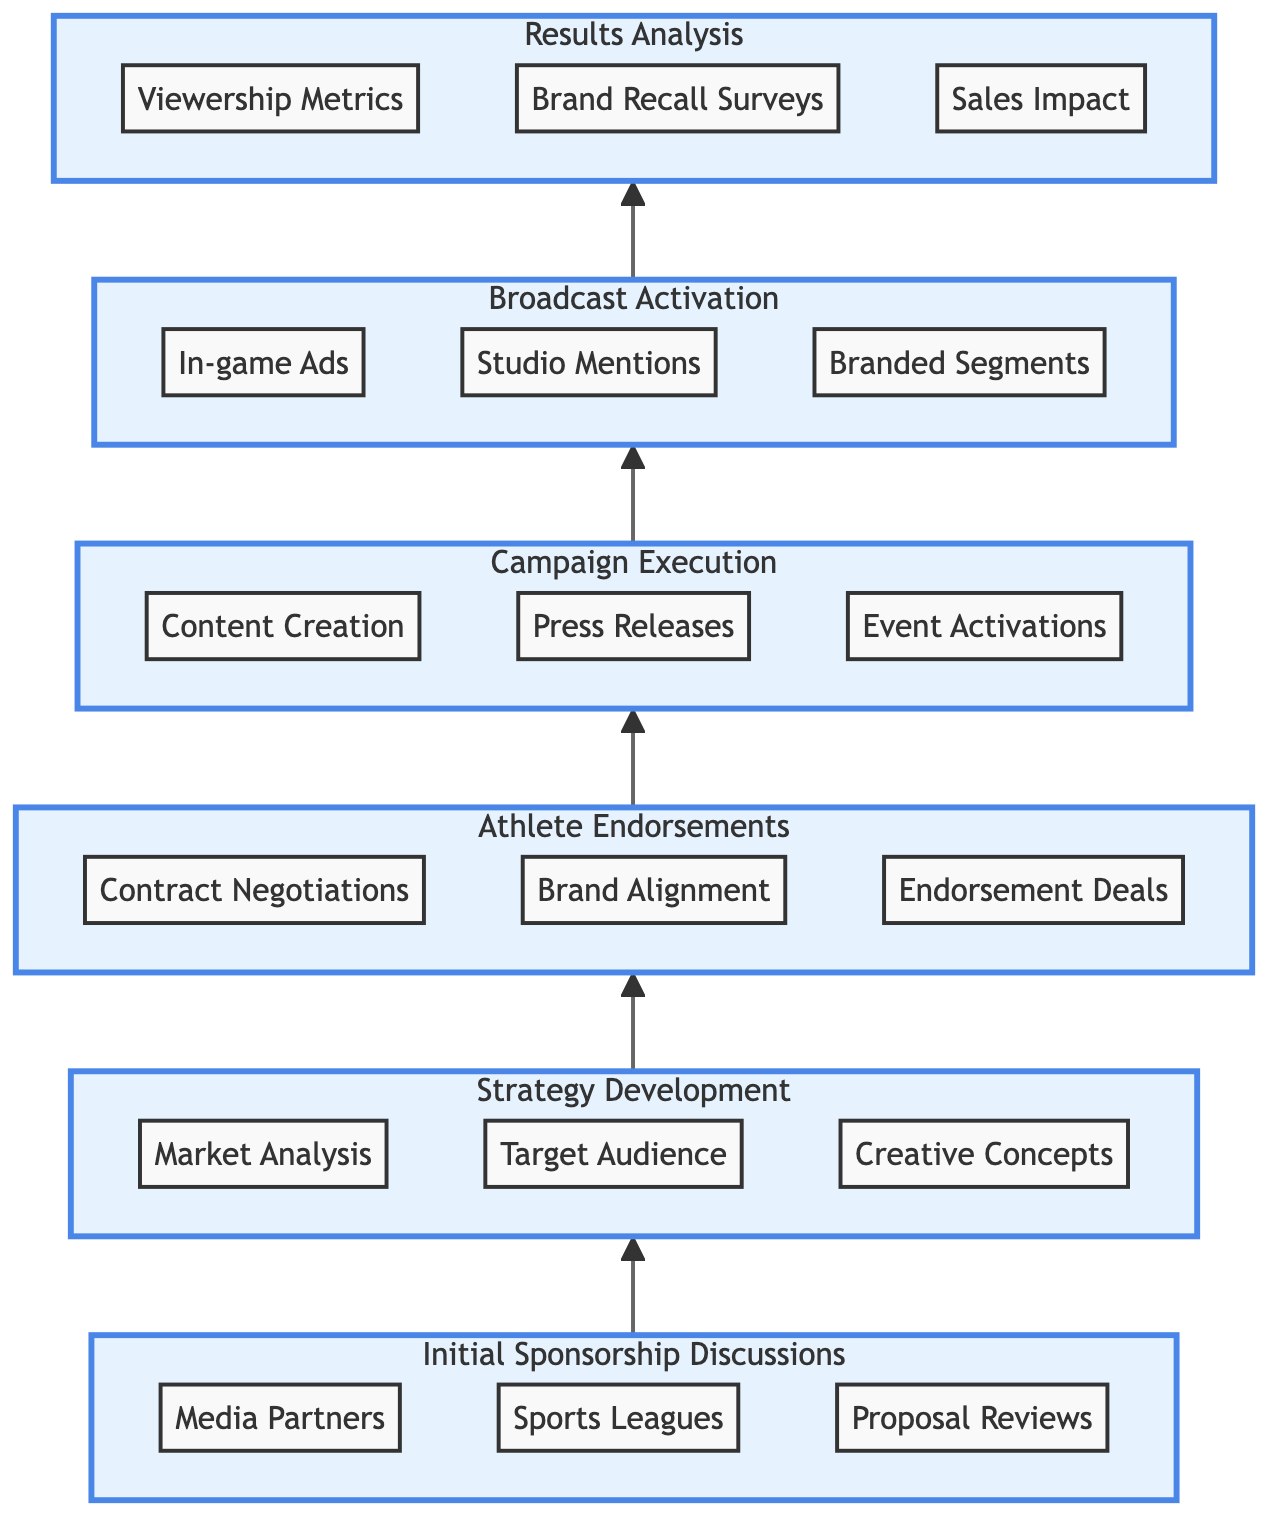What is the first step in the process? The diagram indicates that the first step is "Initial Sponsorship Discussions," which is positioned at the bottom as the starting point of the flow.
Answer: Initial Sponsorship Discussions How many main steps are outlined in the process? By counting the nodes in the diagram, there are five main steps listed: Initial Sponsorship Discussions, Strategy Development, Athlete Endorsements, Campaign Execution, and Results Analysis.
Answer: Five What is the last step of the process? The last step in the process, which is at the top of the diagram, is "Results Analysis."
Answer: Results Analysis Which step follows "Athlete Endorsements"? According to the flow of the diagram, the next step that follows "Athlete Endorsements" is "Campaign Execution."
Answer: Campaign Execution What are the two steps that precede "Broadcast Activation"? The steps that come before "Broadcast Activation" are "Campaign Execution" and "Athlete Endorsements," which can be found by tracing the flow upwards in the diagram.
Answer: Campaign Execution, Athlete Endorsements What is the relationship between “Strategy Development” and “Results Analysis”? “Strategy Development” is directly below “Results Analysis” in the flow, indicating that it is an earlier step in the process that contributes to the insights gained in the final results analysis phase.
Answer: Sequential relationship How many actions are identified under "Campaign Execution"? The diagram shows three actions: "Content Creation," "Press Releases," and "Event Activations" related to the "Campaign Execution" step.
Answer: Three What type of entities are involved in "Athlete Endorsements"? The entities specified under "Athlete Endorsements" are "Nike-sponsored Athletes," "Brand Ambassadors," and "Sports Agents," indicating various stakeholders involved in this step.
Answer: Nike-sponsored Athletes, Brand Ambassadors, Sports Agents What is unique about the direction of the flow chart? The chart is characterized by a bottom-to-top orientation, meaning it flows upward from the initial discussions to the final results analysis, illustrating the step-wise building of the sponsorship activation strategy.
Answer: Bottom-to-top orientation 